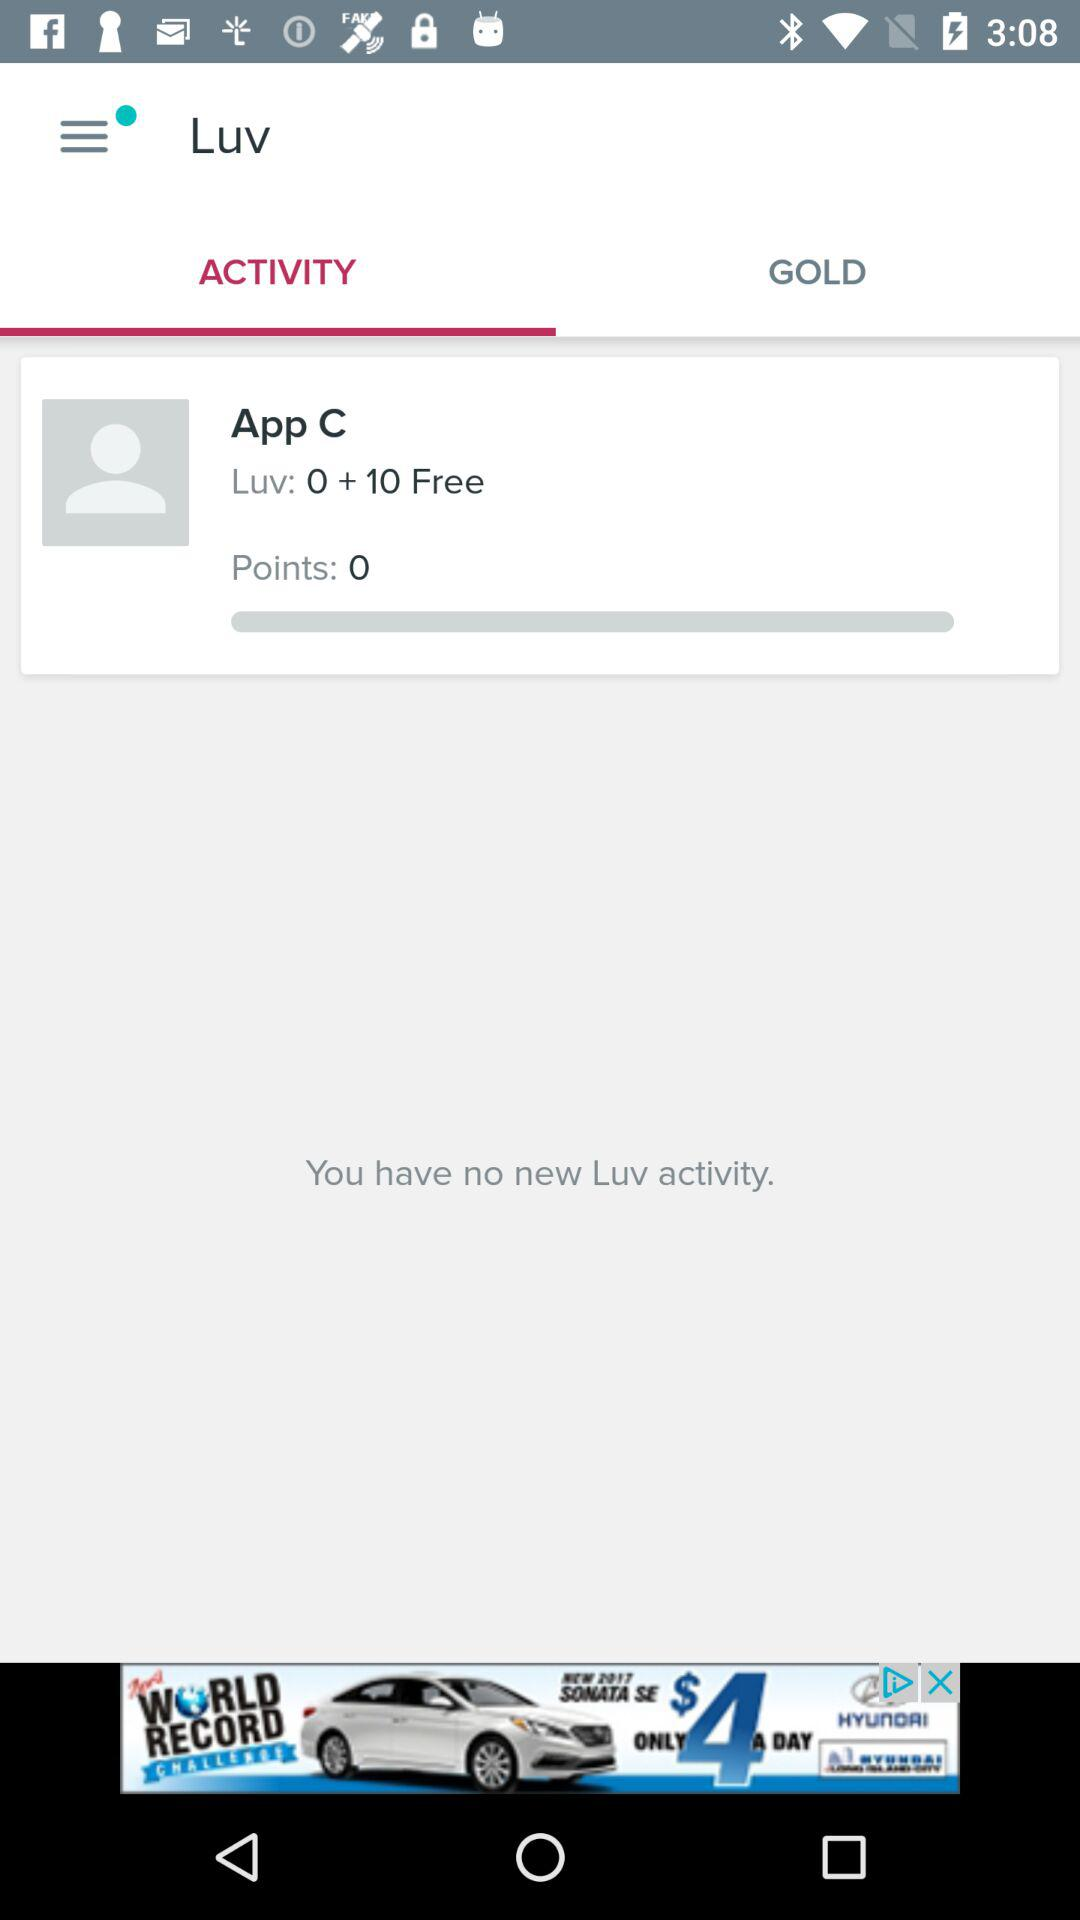Which tab has been selected? The selected tab is "ACTIVITY". 